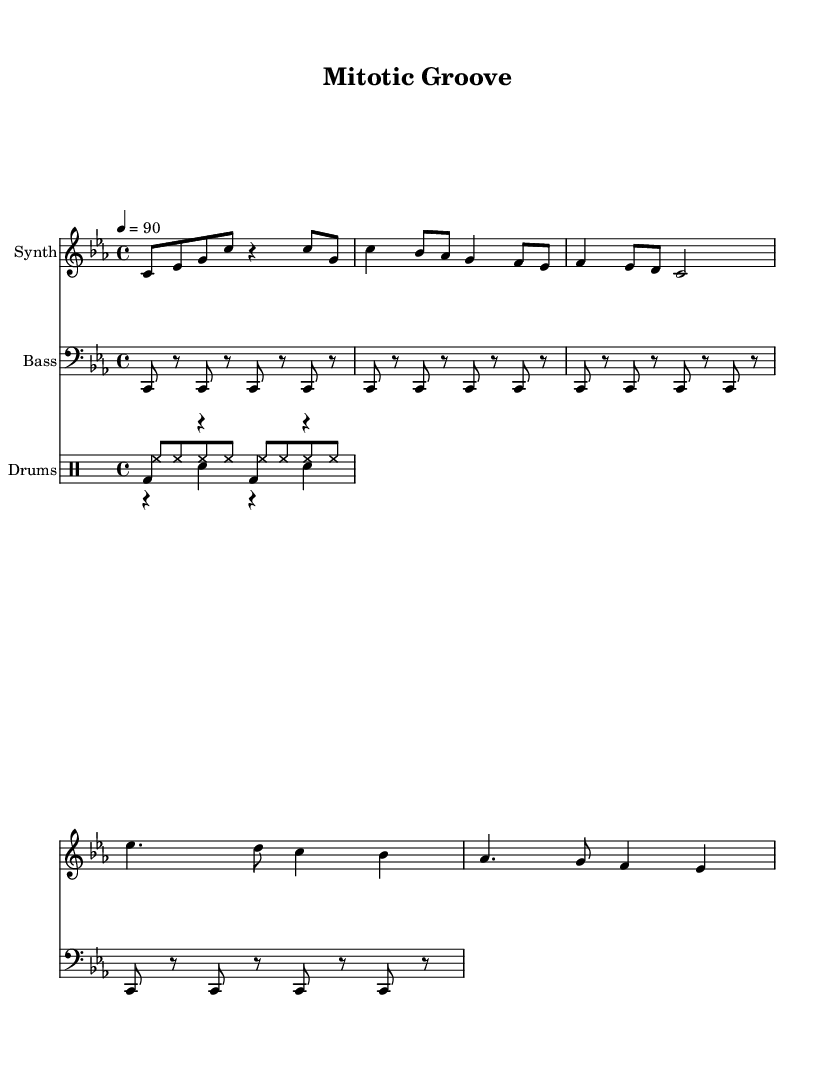What is the key signature of this music? The key signature is indicated by the number of sharps or flats placed at the beginning of the staff. In this sheet music, there are three flats (B flat, E flat, and A flat), indicating it is in C minor.
Answer: C minor What is the time signature of the piece? The time signature is shown at the beginning of the score and indicates the number of beats in each measure. Here, the time signature is 4/4, meaning there are four beats per measure.
Answer: 4/4 What is the tempo marking for this piece? The tempo marking is indicated in beats per minute (bpm) and is found above the music staff. In this score, it states "4 = 90", which means there are 90 beats per minute.
Answer: 90 How many measures are in the synth part? To find the number of measures, count the distinct sections separated by vertical lines (bar lines) in the synth part. There are eight measures in total in the synth part.
Answer: 8 Which instrument plays the kick pattern? The kick pattern is explicitly shown in the drum staff notation. It is labeled as "Drums," and the kick drum is notated in "bd." This implies that the kick pattern is played by the kick drum.
Answer: Kick drum How does the bass pattern relate to the melodic structure? The bass pattern in the sheet music outlines a rhythmic support and foundational tone for the harmonic context, corresponding to the root notes of the synth melody in C minor. Both parts are complementary, with the bass emphasizing the beats while the synth provides melodic variation.
Answer: Complementary 